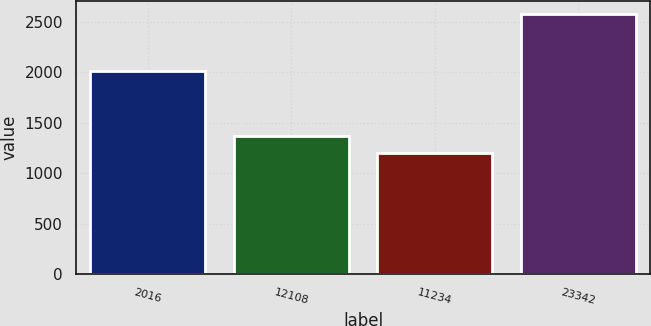Convert chart. <chart><loc_0><loc_0><loc_500><loc_500><bar_chart><fcel>2016<fcel>12108<fcel>11234<fcel>23342<nl><fcel>2014<fcel>1372.2<fcel>1204.9<fcel>2577.1<nl></chart> 